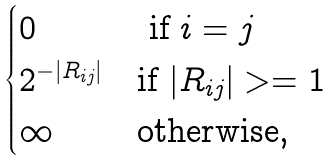<formula> <loc_0><loc_0><loc_500><loc_500>\begin{cases} 0 & \text { if $i = j$} \\ 2 ^ { - | R _ { i j } | } & \text {if $|R_{ij}| >= 1$} \\ \infty & \text {otherwise,} \end{cases}</formula> 